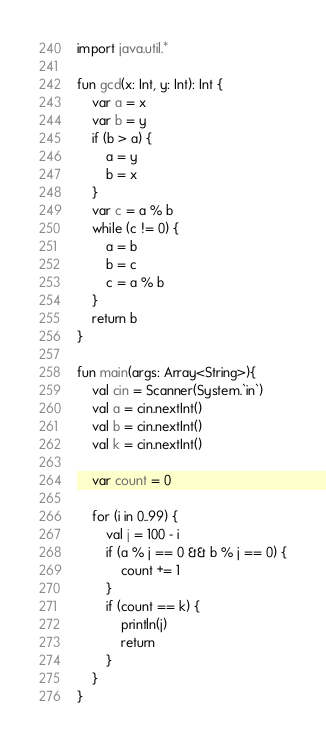<code> <loc_0><loc_0><loc_500><loc_500><_Kotlin_>import java.util.*

fun gcd(x: Int, y: Int): Int {
    var a = x
    var b = y
    if (b > a) {
        a = y
        b = x
    }
    var c = a % b
    while (c != 0) {
        a = b
        b = c
        c = a % b
    }
    return b
}

fun main(args: Array<String>){
	val cin = Scanner(System.`in`)
    val a = cin.nextInt()
    val b = cin.nextInt()
    val k = cin.nextInt()
    
    var count = 0

    for (i in 0..99) {
        val j = 100 - i
        if (a % j == 0 && b % j == 0) {
            count += 1
        }
        if (count == k) {
            println(j)
            return
        }
    }
}</code> 